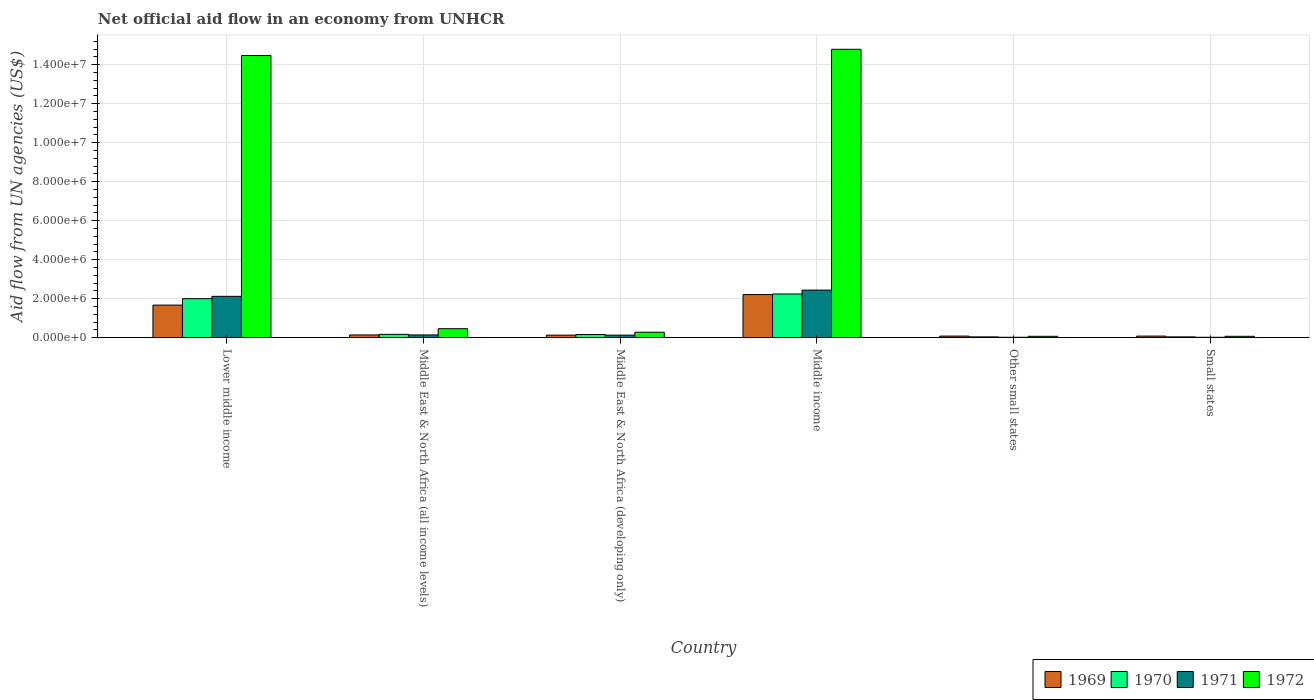How many groups of bars are there?
Your answer should be very brief. 6. Are the number of bars per tick equal to the number of legend labels?
Provide a succinct answer. Yes. How many bars are there on the 4th tick from the right?
Offer a terse response. 4. In how many cases, is the number of bars for a given country not equal to the number of legend labels?
Your answer should be very brief. 0. Across all countries, what is the maximum net official aid flow in 1969?
Make the answer very short. 2.21e+06. In which country was the net official aid flow in 1972 minimum?
Keep it short and to the point. Other small states. What is the total net official aid flow in 1969 in the graph?
Give a very brief answer. 4.31e+06. What is the difference between the net official aid flow in 1969 in Lower middle income and that in Middle income?
Offer a terse response. -5.40e+05. What is the average net official aid flow in 1969 per country?
Ensure brevity in your answer.  7.18e+05. In how many countries, is the net official aid flow in 1970 greater than 10400000 US$?
Ensure brevity in your answer.  0. What is the ratio of the net official aid flow in 1972 in Lower middle income to that in Middle East & North Africa (developing only)?
Your response must be concise. 51.68. What is the difference between the highest and the second highest net official aid flow in 1972?
Provide a short and direct response. 1.43e+07. What is the difference between the highest and the lowest net official aid flow in 1969?
Your answer should be very brief. 2.13e+06. In how many countries, is the net official aid flow in 1971 greater than the average net official aid flow in 1971 taken over all countries?
Make the answer very short. 2. Is it the case that in every country, the sum of the net official aid flow in 1972 and net official aid flow in 1971 is greater than the sum of net official aid flow in 1970 and net official aid flow in 1969?
Offer a very short reply. No. What does the 1st bar from the left in Middle income represents?
Your response must be concise. 1969. What does the 1st bar from the right in Lower middle income represents?
Give a very brief answer. 1972. Is it the case that in every country, the sum of the net official aid flow in 1970 and net official aid flow in 1969 is greater than the net official aid flow in 1972?
Your answer should be compact. No. How many bars are there?
Provide a short and direct response. 24. What is the difference between two consecutive major ticks on the Y-axis?
Give a very brief answer. 2.00e+06. Are the values on the major ticks of Y-axis written in scientific E-notation?
Offer a terse response. Yes. Does the graph contain grids?
Make the answer very short. Yes. What is the title of the graph?
Make the answer very short. Net official aid flow in an economy from UNHCR. Does "1966" appear as one of the legend labels in the graph?
Ensure brevity in your answer.  No. What is the label or title of the Y-axis?
Offer a very short reply. Aid flow from UN agencies (US$). What is the Aid flow from UN agencies (US$) of 1969 in Lower middle income?
Provide a succinct answer. 1.67e+06. What is the Aid flow from UN agencies (US$) of 1971 in Lower middle income?
Provide a short and direct response. 2.12e+06. What is the Aid flow from UN agencies (US$) of 1972 in Lower middle income?
Your answer should be compact. 1.45e+07. What is the Aid flow from UN agencies (US$) of 1970 in Middle East & North Africa (all income levels)?
Provide a short and direct response. 1.70e+05. What is the Aid flow from UN agencies (US$) in 1971 in Middle East & North Africa (all income levels)?
Provide a short and direct response. 1.40e+05. What is the Aid flow from UN agencies (US$) of 1969 in Middle East & North Africa (developing only)?
Provide a succinct answer. 1.30e+05. What is the Aid flow from UN agencies (US$) of 1970 in Middle East & North Africa (developing only)?
Provide a short and direct response. 1.60e+05. What is the Aid flow from UN agencies (US$) of 1971 in Middle East & North Africa (developing only)?
Your answer should be very brief. 1.30e+05. What is the Aid flow from UN agencies (US$) in 1969 in Middle income?
Provide a short and direct response. 2.21e+06. What is the Aid flow from UN agencies (US$) of 1970 in Middle income?
Your answer should be compact. 2.24e+06. What is the Aid flow from UN agencies (US$) of 1971 in Middle income?
Give a very brief answer. 2.44e+06. What is the Aid flow from UN agencies (US$) in 1972 in Middle income?
Provide a short and direct response. 1.48e+07. What is the Aid flow from UN agencies (US$) in 1969 in Other small states?
Your answer should be very brief. 8.00e+04. What is the Aid flow from UN agencies (US$) in 1970 in Other small states?
Keep it short and to the point. 4.00e+04. What is the Aid flow from UN agencies (US$) of 1971 in Other small states?
Ensure brevity in your answer.  2.00e+04. What is the Aid flow from UN agencies (US$) of 1972 in Other small states?
Your answer should be compact. 7.00e+04. What is the Aid flow from UN agencies (US$) in 1970 in Small states?
Your response must be concise. 4.00e+04. What is the Aid flow from UN agencies (US$) in 1971 in Small states?
Your response must be concise. 2.00e+04. Across all countries, what is the maximum Aid flow from UN agencies (US$) in 1969?
Your answer should be very brief. 2.21e+06. Across all countries, what is the maximum Aid flow from UN agencies (US$) in 1970?
Your answer should be very brief. 2.24e+06. Across all countries, what is the maximum Aid flow from UN agencies (US$) of 1971?
Your answer should be compact. 2.44e+06. Across all countries, what is the maximum Aid flow from UN agencies (US$) of 1972?
Your response must be concise. 1.48e+07. What is the total Aid flow from UN agencies (US$) of 1969 in the graph?
Offer a very short reply. 4.31e+06. What is the total Aid flow from UN agencies (US$) in 1970 in the graph?
Keep it short and to the point. 4.65e+06. What is the total Aid flow from UN agencies (US$) of 1971 in the graph?
Offer a terse response. 4.87e+06. What is the total Aid flow from UN agencies (US$) in 1972 in the graph?
Your answer should be compact. 3.01e+07. What is the difference between the Aid flow from UN agencies (US$) in 1969 in Lower middle income and that in Middle East & North Africa (all income levels)?
Provide a short and direct response. 1.53e+06. What is the difference between the Aid flow from UN agencies (US$) in 1970 in Lower middle income and that in Middle East & North Africa (all income levels)?
Provide a short and direct response. 1.83e+06. What is the difference between the Aid flow from UN agencies (US$) of 1971 in Lower middle income and that in Middle East & North Africa (all income levels)?
Offer a terse response. 1.98e+06. What is the difference between the Aid flow from UN agencies (US$) of 1972 in Lower middle income and that in Middle East & North Africa (all income levels)?
Provide a succinct answer. 1.40e+07. What is the difference between the Aid flow from UN agencies (US$) of 1969 in Lower middle income and that in Middle East & North Africa (developing only)?
Your answer should be very brief. 1.54e+06. What is the difference between the Aid flow from UN agencies (US$) in 1970 in Lower middle income and that in Middle East & North Africa (developing only)?
Keep it short and to the point. 1.84e+06. What is the difference between the Aid flow from UN agencies (US$) of 1971 in Lower middle income and that in Middle East & North Africa (developing only)?
Your answer should be very brief. 1.99e+06. What is the difference between the Aid flow from UN agencies (US$) in 1972 in Lower middle income and that in Middle East & North Africa (developing only)?
Your answer should be compact. 1.42e+07. What is the difference between the Aid flow from UN agencies (US$) of 1969 in Lower middle income and that in Middle income?
Keep it short and to the point. -5.40e+05. What is the difference between the Aid flow from UN agencies (US$) in 1971 in Lower middle income and that in Middle income?
Provide a short and direct response. -3.20e+05. What is the difference between the Aid flow from UN agencies (US$) of 1972 in Lower middle income and that in Middle income?
Your answer should be very brief. -3.20e+05. What is the difference between the Aid flow from UN agencies (US$) in 1969 in Lower middle income and that in Other small states?
Your response must be concise. 1.59e+06. What is the difference between the Aid flow from UN agencies (US$) of 1970 in Lower middle income and that in Other small states?
Your answer should be very brief. 1.96e+06. What is the difference between the Aid flow from UN agencies (US$) of 1971 in Lower middle income and that in Other small states?
Make the answer very short. 2.10e+06. What is the difference between the Aid flow from UN agencies (US$) of 1972 in Lower middle income and that in Other small states?
Provide a short and direct response. 1.44e+07. What is the difference between the Aid flow from UN agencies (US$) of 1969 in Lower middle income and that in Small states?
Your answer should be very brief. 1.59e+06. What is the difference between the Aid flow from UN agencies (US$) of 1970 in Lower middle income and that in Small states?
Provide a succinct answer. 1.96e+06. What is the difference between the Aid flow from UN agencies (US$) of 1971 in Lower middle income and that in Small states?
Your answer should be compact. 2.10e+06. What is the difference between the Aid flow from UN agencies (US$) in 1972 in Lower middle income and that in Small states?
Offer a very short reply. 1.44e+07. What is the difference between the Aid flow from UN agencies (US$) of 1969 in Middle East & North Africa (all income levels) and that in Middle East & North Africa (developing only)?
Provide a succinct answer. 10000. What is the difference between the Aid flow from UN agencies (US$) in 1972 in Middle East & North Africa (all income levels) and that in Middle East & North Africa (developing only)?
Provide a succinct answer. 1.80e+05. What is the difference between the Aid flow from UN agencies (US$) in 1969 in Middle East & North Africa (all income levels) and that in Middle income?
Provide a succinct answer. -2.07e+06. What is the difference between the Aid flow from UN agencies (US$) in 1970 in Middle East & North Africa (all income levels) and that in Middle income?
Offer a terse response. -2.07e+06. What is the difference between the Aid flow from UN agencies (US$) in 1971 in Middle East & North Africa (all income levels) and that in Middle income?
Your response must be concise. -2.30e+06. What is the difference between the Aid flow from UN agencies (US$) in 1972 in Middle East & North Africa (all income levels) and that in Middle income?
Provide a succinct answer. -1.43e+07. What is the difference between the Aid flow from UN agencies (US$) of 1969 in Middle East & North Africa (all income levels) and that in Other small states?
Your answer should be very brief. 6.00e+04. What is the difference between the Aid flow from UN agencies (US$) in 1970 in Middle East & North Africa (all income levels) and that in Other small states?
Give a very brief answer. 1.30e+05. What is the difference between the Aid flow from UN agencies (US$) of 1972 in Middle East & North Africa (all income levels) and that in Other small states?
Offer a terse response. 3.90e+05. What is the difference between the Aid flow from UN agencies (US$) of 1969 in Middle East & North Africa (all income levels) and that in Small states?
Keep it short and to the point. 6.00e+04. What is the difference between the Aid flow from UN agencies (US$) of 1971 in Middle East & North Africa (all income levels) and that in Small states?
Keep it short and to the point. 1.20e+05. What is the difference between the Aid flow from UN agencies (US$) of 1972 in Middle East & North Africa (all income levels) and that in Small states?
Make the answer very short. 3.90e+05. What is the difference between the Aid flow from UN agencies (US$) in 1969 in Middle East & North Africa (developing only) and that in Middle income?
Ensure brevity in your answer.  -2.08e+06. What is the difference between the Aid flow from UN agencies (US$) in 1970 in Middle East & North Africa (developing only) and that in Middle income?
Offer a terse response. -2.08e+06. What is the difference between the Aid flow from UN agencies (US$) of 1971 in Middle East & North Africa (developing only) and that in Middle income?
Give a very brief answer. -2.31e+06. What is the difference between the Aid flow from UN agencies (US$) in 1972 in Middle East & North Africa (developing only) and that in Middle income?
Your answer should be compact. -1.45e+07. What is the difference between the Aid flow from UN agencies (US$) of 1969 in Middle East & North Africa (developing only) and that in Other small states?
Provide a succinct answer. 5.00e+04. What is the difference between the Aid flow from UN agencies (US$) in 1972 in Middle East & North Africa (developing only) and that in Other small states?
Your response must be concise. 2.10e+05. What is the difference between the Aid flow from UN agencies (US$) in 1969 in Middle East & North Africa (developing only) and that in Small states?
Keep it short and to the point. 5.00e+04. What is the difference between the Aid flow from UN agencies (US$) in 1971 in Middle East & North Africa (developing only) and that in Small states?
Ensure brevity in your answer.  1.10e+05. What is the difference between the Aid flow from UN agencies (US$) in 1969 in Middle income and that in Other small states?
Offer a very short reply. 2.13e+06. What is the difference between the Aid flow from UN agencies (US$) of 1970 in Middle income and that in Other small states?
Provide a short and direct response. 2.20e+06. What is the difference between the Aid flow from UN agencies (US$) of 1971 in Middle income and that in Other small states?
Provide a succinct answer. 2.42e+06. What is the difference between the Aid flow from UN agencies (US$) of 1972 in Middle income and that in Other small states?
Your answer should be compact. 1.47e+07. What is the difference between the Aid flow from UN agencies (US$) of 1969 in Middle income and that in Small states?
Make the answer very short. 2.13e+06. What is the difference between the Aid flow from UN agencies (US$) in 1970 in Middle income and that in Small states?
Provide a succinct answer. 2.20e+06. What is the difference between the Aid flow from UN agencies (US$) of 1971 in Middle income and that in Small states?
Provide a succinct answer. 2.42e+06. What is the difference between the Aid flow from UN agencies (US$) of 1972 in Middle income and that in Small states?
Offer a terse response. 1.47e+07. What is the difference between the Aid flow from UN agencies (US$) in 1970 in Other small states and that in Small states?
Offer a terse response. 0. What is the difference between the Aid flow from UN agencies (US$) of 1971 in Other small states and that in Small states?
Provide a short and direct response. 0. What is the difference between the Aid flow from UN agencies (US$) in 1972 in Other small states and that in Small states?
Your response must be concise. 0. What is the difference between the Aid flow from UN agencies (US$) of 1969 in Lower middle income and the Aid flow from UN agencies (US$) of 1970 in Middle East & North Africa (all income levels)?
Keep it short and to the point. 1.50e+06. What is the difference between the Aid flow from UN agencies (US$) of 1969 in Lower middle income and the Aid flow from UN agencies (US$) of 1971 in Middle East & North Africa (all income levels)?
Give a very brief answer. 1.53e+06. What is the difference between the Aid flow from UN agencies (US$) in 1969 in Lower middle income and the Aid flow from UN agencies (US$) in 1972 in Middle East & North Africa (all income levels)?
Offer a very short reply. 1.21e+06. What is the difference between the Aid flow from UN agencies (US$) of 1970 in Lower middle income and the Aid flow from UN agencies (US$) of 1971 in Middle East & North Africa (all income levels)?
Give a very brief answer. 1.86e+06. What is the difference between the Aid flow from UN agencies (US$) in 1970 in Lower middle income and the Aid flow from UN agencies (US$) in 1972 in Middle East & North Africa (all income levels)?
Offer a very short reply. 1.54e+06. What is the difference between the Aid flow from UN agencies (US$) in 1971 in Lower middle income and the Aid flow from UN agencies (US$) in 1972 in Middle East & North Africa (all income levels)?
Offer a very short reply. 1.66e+06. What is the difference between the Aid flow from UN agencies (US$) in 1969 in Lower middle income and the Aid flow from UN agencies (US$) in 1970 in Middle East & North Africa (developing only)?
Your response must be concise. 1.51e+06. What is the difference between the Aid flow from UN agencies (US$) of 1969 in Lower middle income and the Aid flow from UN agencies (US$) of 1971 in Middle East & North Africa (developing only)?
Your answer should be very brief. 1.54e+06. What is the difference between the Aid flow from UN agencies (US$) in 1969 in Lower middle income and the Aid flow from UN agencies (US$) in 1972 in Middle East & North Africa (developing only)?
Offer a very short reply. 1.39e+06. What is the difference between the Aid flow from UN agencies (US$) in 1970 in Lower middle income and the Aid flow from UN agencies (US$) in 1971 in Middle East & North Africa (developing only)?
Make the answer very short. 1.87e+06. What is the difference between the Aid flow from UN agencies (US$) in 1970 in Lower middle income and the Aid flow from UN agencies (US$) in 1972 in Middle East & North Africa (developing only)?
Keep it short and to the point. 1.72e+06. What is the difference between the Aid flow from UN agencies (US$) of 1971 in Lower middle income and the Aid flow from UN agencies (US$) of 1972 in Middle East & North Africa (developing only)?
Provide a short and direct response. 1.84e+06. What is the difference between the Aid flow from UN agencies (US$) of 1969 in Lower middle income and the Aid flow from UN agencies (US$) of 1970 in Middle income?
Offer a very short reply. -5.70e+05. What is the difference between the Aid flow from UN agencies (US$) in 1969 in Lower middle income and the Aid flow from UN agencies (US$) in 1971 in Middle income?
Keep it short and to the point. -7.70e+05. What is the difference between the Aid flow from UN agencies (US$) in 1969 in Lower middle income and the Aid flow from UN agencies (US$) in 1972 in Middle income?
Provide a short and direct response. -1.31e+07. What is the difference between the Aid flow from UN agencies (US$) of 1970 in Lower middle income and the Aid flow from UN agencies (US$) of 1971 in Middle income?
Provide a short and direct response. -4.40e+05. What is the difference between the Aid flow from UN agencies (US$) of 1970 in Lower middle income and the Aid flow from UN agencies (US$) of 1972 in Middle income?
Make the answer very short. -1.28e+07. What is the difference between the Aid flow from UN agencies (US$) in 1971 in Lower middle income and the Aid flow from UN agencies (US$) in 1972 in Middle income?
Your response must be concise. -1.27e+07. What is the difference between the Aid flow from UN agencies (US$) in 1969 in Lower middle income and the Aid flow from UN agencies (US$) in 1970 in Other small states?
Provide a succinct answer. 1.63e+06. What is the difference between the Aid flow from UN agencies (US$) in 1969 in Lower middle income and the Aid flow from UN agencies (US$) in 1971 in Other small states?
Your answer should be very brief. 1.65e+06. What is the difference between the Aid flow from UN agencies (US$) in 1969 in Lower middle income and the Aid flow from UN agencies (US$) in 1972 in Other small states?
Make the answer very short. 1.60e+06. What is the difference between the Aid flow from UN agencies (US$) in 1970 in Lower middle income and the Aid flow from UN agencies (US$) in 1971 in Other small states?
Offer a very short reply. 1.98e+06. What is the difference between the Aid flow from UN agencies (US$) in 1970 in Lower middle income and the Aid flow from UN agencies (US$) in 1972 in Other small states?
Make the answer very short. 1.93e+06. What is the difference between the Aid flow from UN agencies (US$) of 1971 in Lower middle income and the Aid flow from UN agencies (US$) of 1972 in Other small states?
Your response must be concise. 2.05e+06. What is the difference between the Aid flow from UN agencies (US$) of 1969 in Lower middle income and the Aid flow from UN agencies (US$) of 1970 in Small states?
Offer a terse response. 1.63e+06. What is the difference between the Aid flow from UN agencies (US$) in 1969 in Lower middle income and the Aid flow from UN agencies (US$) in 1971 in Small states?
Ensure brevity in your answer.  1.65e+06. What is the difference between the Aid flow from UN agencies (US$) of 1969 in Lower middle income and the Aid flow from UN agencies (US$) of 1972 in Small states?
Offer a very short reply. 1.60e+06. What is the difference between the Aid flow from UN agencies (US$) of 1970 in Lower middle income and the Aid flow from UN agencies (US$) of 1971 in Small states?
Your response must be concise. 1.98e+06. What is the difference between the Aid flow from UN agencies (US$) of 1970 in Lower middle income and the Aid flow from UN agencies (US$) of 1972 in Small states?
Provide a short and direct response. 1.93e+06. What is the difference between the Aid flow from UN agencies (US$) of 1971 in Lower middle income and the Aid flow from UN agencies (US$) of 1972 in Small states?
Offer a very short reply. 2.05e+06. What is the difference between the Aid flow from UN agencies (US$) in 1969 in Middle East & North Africa (all income levels) and the Aid flow from UN agencies (US$) in 1972 in Middle East & North Africa (developing only)?
Keep it short and to the point. -1.40e+05. What is the difference between the Aid flow from UN agencies (US$) in 1970 in Middle East & North Africa (all income levels) and the Aid flow from UN agencies (US$) in 1971 in Middle East & North Africa (developing only)?
Keep it short and to the point. 4.00e+04. What is the difference between the Aid flow from UN agencies (US$) of 1971 in Middle East & North Africa (all income levels) and the Aid flow from UN agencies (US$) of 1972 in Middle East & North Africa (developing only)?
Your response must be concise. -1.40e+05. What is the difference between the Aid flow from UN agencies (US$) of 1969 in Middle East & North Africa (all income levels) and the Aid flow from UN agencies (US$) of 1970 in Middle income?
Provide a succinct answer. -2.10e+06. What is the difference between the Aid flow from UN agencies (US$) of 1969 in Middle East & North Africa (all income levels) and the Aid flow from UN agencies (US$) of 1971 in Middle income?
Keep it short and to the point. -2.30e+06. What is the difference between the Aid flow from UN agencies (US$) of 1969 in Middle East & North Africa (all income levels) and the Aid flow from UN agencies (US$) of 1972 in Middle income?
Make the answer very short. -1.46e+07. What is the difference between the Aid flow from UN agencies (US$) of 1970 in Middle East & North Africa (all income levels) and the Aid flow from UN agencies (US$) of 1971 in Middle income?
Offer a very short reply. -2.27e+06. What is the difference between the Aid flow from UN agencies (US$) in 1970 in Middle East & North Africa (all income levels) and the Aid flow from UN agencies (US$) in 1972 in Middle income?
Offer a very short reply. -1.46e+07. What is the difference between the Aid flow from UN agencies (US$) in 1971 in Middle East & North Africa (all income levels) and the Aid flow from UN agencies (US$) in 1972 in Middle income?
Offer a very short reply. -1.46e+07. What is the difference between the Aid flow from UN agencies (US$) of 1969 in Middle East & North Africa (all income levels) and the Aid flow from UN agencies (US$) of 1970 in Other small states?
Your answer should be compact. 1.00e+05. What is the difference between the Aid flow from UN agencies (US$) of 1969 in Middle East & North Africa (all income levels) and the Aid flow from UN agencies (US$) of 1971 in Other small states?
Your response must be concise. 1.20e+05. What is the difference between the Aid flow from UN agencies (US$) in 1969 in Middle East & North Africa (all income levels) and the Aid flow from UN agencies (US$) in 1971 in Small states?
Provide a short and direct response. 1.20e+05. What is the difference between the Aid flow from UN agencies (US$) of 1969 in Middle East & North Africa (all income levels) and the Aid flow from UN agencies (US$) of 1972 in Small states?
Your response must be concise. 7.00e+04. What is the difference between the Aid flow from UN agencies (US$) in 1969 in Middle East & North Africa (developing only) and the Aid flow from UN agencies (US$) in 1970 in Middle income?
Offer a terse response. -2.11e+06. What is the difference between the Aid flow from UN agencies (US$) in 1969 in Middle East & North Africa (developing only) and the Aid flow from UN agencies (US$) in 1971 in Middle income?
Provide a short and direct response. -2.31e+06. What is the difference between the Aid flow from UN agencies (US$) of 1969 in Middle East & North Africa (developing only) and the Aid flow from UN agencies (US$) of 1972 in Middle income?
Provide a succinct answer. -1.47e+07. What is the difference between the Aid flow from UN agencies (US$) of 1970 in Middle East & North Africa (developing only) and the Aid flow from UN agencies (US$) of 1971 in Middle income?
Your answer should be compact. -2.28e+06. What is the difference between the Aid flow from UN agencies (US$) of 1970 in Middle East & North Africa (developing only) and the Aid flow from UN agencies (US$) of 1972 in Middle income?
Offer a very short reply. -1.46e+07. What is the difference between the Aid flow from UN agencies (US$) of 1971 in Middle East & North Africa (developing only) and the Aid flow from UN agencies (US$) of 1972 in Middle income?
Give a very brief answer. -1.47e+07. What is the difference between the Aid flow from UN agencies (US$) in 1969 in Middle East & North Africa (developing only) and the Aid flow from UN agencies (US$) in 1970 in Other small states?
Keep it short and to the point. 9.00e+04. What is the difference between the Aid flow from UN agencies (US$) of 1969 in Middle East & North Africa (developing only) and the Aid flow from UN agencies (US$) of 1971 in Other small states?
Provide a short and direct response. 1.10e+05. What is the difference between the Aid flow from UN agencies (US$) of 1969 in Middle East & North Africa (developing only) and the Aid flow from UN agencies (US$) of 1972 in Other small states?
Your response must be concise. 6.00e+04. What is the difference between the Aid flow from UN agencies (US$) of 1970 in Middle East & North Africa (developing only) and the Aid flow from UN agencies (US$) of 1971 in Other small states?
Your answer should be compact. 1.40e+05. What is the difference between the Aid flow from UN agencies (US$) of 1971 in Middle East & North Africa (developing only) and the Aid flow from UN agencies (US$) of 1972 in Other small states?
Your answer should be compact. 6.00e+04. What is the difference between the Aid flow from UN agencies (US$) in 1969 in Middle East & North Africa (developing only) and the Aid flow from UN agencies (US$) in 1970 in Small states?
Ensure brevity in your answer.  9.00e+04. What is the difference between the Aid flow from UN agencies (US$) of 1970 in Middle East & North Africa (developing only) and the Aid flow from UN agencies (US$) of 1972 in Small states?
Give a very brief answer. 9.00e+04. What is the difference between the Aid flow from UN agencies (US$) of 1969 in Middle income and the Aid flow from UN agencies (US$) of 1970 in Other small states?
Offer a terse response. 2.17e+06. What is the difference between the Aid flow from UN agencies (US$) of 1969 in Middle income and the Aid flow from UN agencies (US$) of 1971 in Other small states?
Keep it short and to the point. 2.19e+06. What is the difference between the Aid flow from UN agencies (US$) of 1969 in Middle income and the Aid flow from UN agencies (US$) of 1972 in Other small states?
Your answer should be very brief. 2.14e+06. What is the difference between the Aid flow from UN agencies (US$) in 1970 in Middle income and the Aid flow from UN agencies (US$) in 1971 in Other small states?
Your answer should be compact. 2.22e+06. What is the difference between the Aid flow from UN agencies (US$) of 1970 in Middle income and the Aid flow from UN agencies (US$) of 1972 in Other small states?
Offer a terse response. 2.17e+06. What is the difference between the Aid flow from UN agencies (US$) of 1971 in Middle income and the Aid flow from UN agencies (US$) of 1972 in Other small states?
Keep it short and to the point. 2.37e+06. What is the difference between the Aid flow from UN agencies (US$) of 1969 in Middle income and the Aid flow from UN agencies (US$) of 1970 in Small states?
Provide a short and direct response. 2.17e+06. What is the difference between the Aid flow from UN agencies (US$) in 1969 in Middle income and the Aid flow from UN agencies (US$) in 1971 in Small states?
Make the answer very short. 2.19e+06. What is the difference between the Aid flow from UN agencies (US$) in 1969 in Middle income and the Aid flow from UN agencies (US$) in 1972 in Small states?
Provide a short and direct response. 2.14e+06. What is the difference between the Aid flow from UN agencies (US$) in 1970 in Middle income and the Aid flow from UN agencies (US$) in 1971 in Small states?
Keep it short and to the point. 2.22e+06. What is the difference between the Aid flow from UN agencies (US$) of 1970 in Middle income and the Aid flow from UN agencies (US$) of 1972 in Small states?
Provide a short and direct response. 2.17e+06. What is the difference between the Aid flow from UN agencies (US$) in 1971 in Middle income and the Aid flow from UN agencies (US$) in 1972 in Small states?
Offer a terse response. 2.37e+06. What is the difference between the Aid flow from UN agencies (US$) in 1969 in Other small states and the Aid flow from UN agencies (US$) in 1971 in Small states?
Your response must be concise. 6.00e+04. What is the difference between the Aid flow from UN agencies (US$) in 1969 in Other small states and the Aid flow from UN agencies (US$) in 1972 in Small states?
Provide a short and direct response. 10000. What is the difference between the Aid flow from UN agencies (US$) in 1970 in Other small states and the Aid flow from UN agencies (US$) in 1972 in Small states?
Your answer should be very brief. -3.00e+04. What is the average Aid flow from UN agencies (US$) of 1969 per country?
Keep it short and to the point. 7.18e+05. What is the average Aid flow from UN agencies (US$) in 1970 per country?
Provide a succinct answer. 7.75e+05. What is the average Aid flow from UN agencies (US$) of 1971 per country?
Give a very brief answer. 8.12e+05. What is the average Aid flow from UN agencies (US$) in 1972 per country?
Offer a very short reply. 5.02e+06. What is the difference between the Aid flow from UN agencies (US$) of 1969 and Aid flow from UN agencies (US$) of 1970 in Lower middle income?
Offer a terse response. -3.30e+05. What is the difference between the Aid flow from UN agencies (US$) in 1969 and Aid flow from UN agencies (US$) in 1971 in Lower middle income?
Offer a very short reply. -4.50e+05. What is the difference between the Aid flow from UN agencies (US$) of 1969 and Aid flow from UN agencies (US$) of 1972 in Lower middle income?
Offer a very short reply. -1.28e+07. What is the difference between the Aid flow from UN agencies (US$) of 1970 and Aid flow from UN agencies (US$) of 1972 in Lower middle income?
Your answer should be compact. -1.25e+07. What is the difference between the Aid flow from UN agencies (US$) of 1971 and Aid flow from UN agencies (US$) of 1972 in Lower middle income?
Ensure brevity in your answer.  -1.24e+07. What is the difference between the Aid flow from UN agencies (US$) of 1969 and Aid flow from UN agencies (US$) of 1970 in Middle East & North Africa (all income levels)?
Provide a short and direct response. -3.00e+04. What is the difference between the Aid flow from UN agencies (US$) in 1969 and Aid flow from UN agencies (US$) in 1971 in Middle East & North Africa (all income levels)?
Provide a short and direct response. 0. What is the difference between the Aid flow from UN agencies (US$) in 1969 and Aid flow from UN agencies (US$) in 1972 in Middle East & North Africa (all income levels)?
Make the answer very short. -3.20e+05. What is the difference between the Aid flow from UN agencies (US$) in 1970 and Aid flow from UN agencies (US$) in 1971 in Middle East & North Africa (all income levels)?
Provide a short and direct response. 3.00e+04. What is the difference between the Aid flow from UN agencies (US$) in 1970 and Aid flow from UN agencies (US$) in 1972 in Middle East & North Africa (all income levels)?
Ensure brevity in your answer.  -2.90e+05. What is the difference between the Aid flow from UN agencies (US$) of 1971 and Aid flow from UN agencies (US$) of 1972 in Middle East & North Africa (all income levels)?
Offer a terse response. -3.20e+05. What is the difference between the Aid flow from UN agencies (US$) in 1969 and Aid flow from UN agencies (US$) in 1970 in Middle East & North Africa (developing only)?
Keep it short and to the point. -3.00e+04. What is the difference between the Aid flow from UN agencies (US$) of 1969 and Aid flow from UN agencies (US$) of 1971 in Middle East & North Africa (developing only)?
Provide a short and direct response. 0. What is the difference between the Aid flow from UN agencies (US$) in 1970 and Aid flow from UN agencies (US$) in 1972 in Middle East & North Africa (developing only)?
Ensure brevity in your answer.  -1.20e+05. What is the difference between the Aid flow from UN agencies (US$) in 1969 and Aid flow from UN agencies (US$) in 1970 in Middle income?
Give a very brief answer. -3.00e+04. What is the difference between the Aid flow from UN agencies (US$) of 1969 and Aid flow from UN agencies (US$) of 1972 in Middle income?
Your response must be concise. -1.26e+07. What is the difference between the Aid flow from UN agencies (US$) in 1970 and Aid flow from UN agencies (US$) in 1972 in Middle income?
Make the answer very short. -1.26e+07. What is the difference between the Aid flow from UN agencies (US$) of 1971 and Aid flow from UN agencies (US$) of 1972 in Middle income?
Make the answer very short. -1.24e+07. What is the difference between the Aid flow from UN agencies (US$) in 1969 and Aid flow from UN agencies (US$) in 1970 in Other small states?
Offer a very short reply. 4.00e+04. What is the difference between the Aid flow from UN agencies (US$) in 1969 and Aid flow from UN agencies (US$) in 1971 in Other small states?
Provide a short and direct response. 6.00e+04. What is the difference between the Aid flow from UN agencies (US$) of 1970 and Aid flow from UN agencies (US$) of 1971 in Other small states?
Provide a succinct answer. 2.00e+04. What is the difference between the Aid flow from UN agencies (US$) in 1970 and Aid flow from UN agencies (US$) in 1971 in Small states?
Offer a very short reply. 2.00e+04. What is the difference between the Aid flow from UN agencies (US$) in 1970 and Aid flow from UN agencies (US$) in 1972 in Small states?
Provide a succinct answer. -3.00e+04. What is the ratio of the Aid flow from UN agencies (US$) in 1969 in Lower middle income to that in Middle East & North Africa (all income levels)?
Your response must be concise. 11.93. What is the ratio of the Aid flow from UN agencies (US$) in 1970 in Lower middle income to that in Middle East & North Africa (all income levels)?
Keep it short and to the point. 11.76. What is the ratio of the Aid flow from UN agencies (US$) of 1971 in Lower middle income to that in Middle East & North Africa (all income levels)?
Give a very brief answer. 15.14. What is the ratio of the Aid flow from UN agencies (US$) in 1972 in Lower middle income to that in Middle East & North Africa (all income levels)?
Provide a short and direct response. 31.46. What is the ratio of the Aid flow from UN agencies (US$) in 1969 in Lower middle income to that in Middle East & North Africa (developing only)?
Your answer should be compact. 12.85. What is the ratio of the Aid flow from UN agencies (US$) in 1971 in Lower middle income to that in Middle East & North Africa (developing only)?
Give a very brief answer. 16.31. What is the ratio of the Aid flow from UN agencies (US$) in 1972 in Lower middle income to that in Middle East & North Africa (developing only)?
Keep it short and to the point. 51.68. What is the ratio of the Aid flow from UN agencies (US$) in 1969 in Lower middle income to that in Middle income?
Offer a terse response. 0.76. What is the ratio of the Aid flow from UN agencies (US$) of 1970 in Lower middle income to that in Middle income?
Offer a terse response. 0.89. What is the ratio of the Aid flow from UN agencies (US$) of 1971 in Lower middle income to that in Middle income?
Make the answer very short. 0.87. What is the ratio of the Aid flow from UN agencies (US$) of 1972 in Lower middle income to that in Middle income?
Provide a succinct answer. 0.98. What is the ratio of the Aid flow from UN agencies (US$) of 1969 in Lower middle income to that in Other small states?
Ensure brevity in your answer.  20.88. What is the ratio of the Aid flow from UN agencies (US$) of 1970 in Lower middle income to that in Other small states?
Your answer should be very brief. 50. What is the ratio of the Aid flow from UN agencies (US$) of 1971 in Lower middle income to that in Other small states?
Ensure brevity in your answer.  106. What is the ratio of the Aid flow from UN agencies (US$) of 1972 in Lower middle income to that in Other small states?
Your response must be concise. 206.71. What is the ratio of the Aid flow from UN agencies (US$) of 1969 in Lower middle income to that in Small states?
Your answer should be compact. 20.88. What is the ratio of the Aid flow from UN agencies (US$) in 1971 in Lower middle income to that in Small states?
Provide a short and direct response. 106. What is the ratio of the Aid flow from UN agencies (US$) of 1972 in Lower middle income to that in Small states?
Make the answer very short. 206.71. What is the ratio of the Aid flow from UN agencies (US$) of 1971 in Middle East & North Africa (all income levels) to that in Middle East & North Africa (developing only)?
Your response must be concise. 1.08. What is the ratio of the Aid flow from UN agencies (US$) of 1972 in Middle East & North Africa (all income levels) to that in Middle East & North Africa (developing only)?
Provide a short and direct response. 1.64. What is the ratio of the Aid flow from UN agencies (US$) of 1969 in Middle East & North Africa (all income levels) to that in Middle income?
Offer a very short reply. 0.06. What is the ratio of the Aid flow from UN agencies (US$) in 1970 in Middle East & North Africa (all income levels) to that in Middle income?
Your response must be concise. 0.08. What is the ratio of the Aid flow from UN agencies (US$) in 1971 in Middle East & North Africa (all income levels) to that in Middle income?
Provide a short and direct response. 0.06. What is the ratio of the Aid flow from UN agencies (US$) of 1972 in Middle East & North Africa (all income levels) to that in Middle income?
Your response must be concise. 0.03. What is the ratio of the Aid flow from UN agencies (US$) of 1970 in Middle East & North Africa (all income levels) to that in Other small states?
Ensure brevity in your answer.  4.25. What is the ratio of the Aid flow from UN agencies (US$) of 1971 in Middle East & North Africa (all income levels) to that in Other small states?
Your answer should be compact. 7. What is the ratio of the Aid flow from UN agencies (US$) in 1972 in Middle East & North Africa (all income levels) to that in Other small states?
Your answer should be compact. 6.57. What is the ratio of the Aid flow from UN agencies (US$) in 1970 in Middle East & North Africa (all income levels) to that in Small states?
Keep it short and to the point. 4.25. What is the ratio of the Aid flow from UN agencies (US$) of 1971 in Middle East & North Africa (all income levels) to that in Small states?
Provide a short and direct response. 7. What is the ratio of the Aid flow from UN agencies (US$) in 1972 in Middle East & North Africa (all income levels) to that in Small states?
Make the answer very short. 6.57. What is the ratio of the Aid flow from UN agencies (US$) in 1969 in Middle East & North Africa (developing only) to that in Middle income?
Keep it short and to the point. 0.06. What is the ratio of the Aid flow from UN agencies (US$) in 1970 in Middle East & North Africa (developing only) to that in Middle income?
Keep it short and to the point. 0.07. What is the ratio of the Aid flow from UN agencies (US$) of 1971 in Middle East & North Africa (developing only) to that in Middle income?
Provide a succinct answer. 0.05. What is the ratio of the Aid flow from UN agencies (US$) of 1972 in Middle East & North Africa (developing only) to that in Middle income?
Keep it short and to the point. 0.02. What is the ratio of the Aid flow from UN agencies (US$) in 1969 in Middle East & North Africa (developing only) to that in Other small states?
Offer a very short reply. 1.62. What is the ratio of the Aid flow from UN agencies (US$) in 1972 in Middle East & North Africa (developing only) to that in Other small states?
Ensure brevity in your answer.  4. What is the ratio of the Aid flow from UN agencies (US$) of 1969 in Middle East & North Africa (developing only) to that in Small states?
Provide a short and direct response. 1.62. What is the ratio of the Aid flow from UN agencies (US$) in 1970 in Middle East & North Africa (developing only) to that in Small states?
Ensure brevity in your answer.  4. What is the ratio of the Aid flow from UN agencies (US$) in 1969 in Middle income to that in Other small states?
Keep it short and to the point. 27.62. What is the ratio of the Aid flow from UN agencies (US$) in 1970 in Middle income to that in Other small states?
Your answer should be compact. 56. What is the ratio of the Aid flow from UN agencies (US$) in 1971 in Middle income to that in Other small states?
Keep it short and to the point. 122. What is the ratio of the Aid flow from UN agencies (US$) of 1972 in Middle income to that in Other small states?
Provide a succinct answer. 211.29. What is the ratio of the Aid flow from UN agencies (US$) in 1969 in Middle income to that in Small states?
Provide a succinct answer. 27.62. What is the ratio of the Aid flow from UN agencies (US$) of 1970 in Middle income to that in Small states?
Give a very brief answer. 56. What is the ratio of the Aid flow from UN agencies (US$) of 1971 in Middle income to that in Small states?
Offer a terse response. 122. What is the ratio of the Aid flow from UN agencies (US$) in 1972 in Middle income to that in Small states?
Your answer should be very brief. 211.29. What is the ratio of the Aid flow from UN agencies (US$) of 1970 in Other small states to that in Small states?
Provide a succinct answer. 1. What is the difference between the highest and the second highest Aid flow from UN agencies (US$) of 1969?
Your answer should be compact. 5.40e+05. What is the difference between the highest and the second highest Aid flow from UN agencies (US$) of 1972?
Your response must be concise. 3.20e+05. What is the difference between the highest and the lowest Aid flow from UN agencies (US$) in 1969?
Provide a short and direct response. 2.13e+06. What is the difference between the highest and the lowest Aid flow from UN agencies (US$) of 1970?
Make the answer very short. 2.20e+06. What is the difference between the highest and the lowest Aid flow from UN agencies (US$) of 1971?
Provide a succinct answer. 2.42e+06. What is the difference between the highest and the lowest Aid flow from UN agencies (US$) of 1972?
Your answer should be very brief. 1.47e+07. 